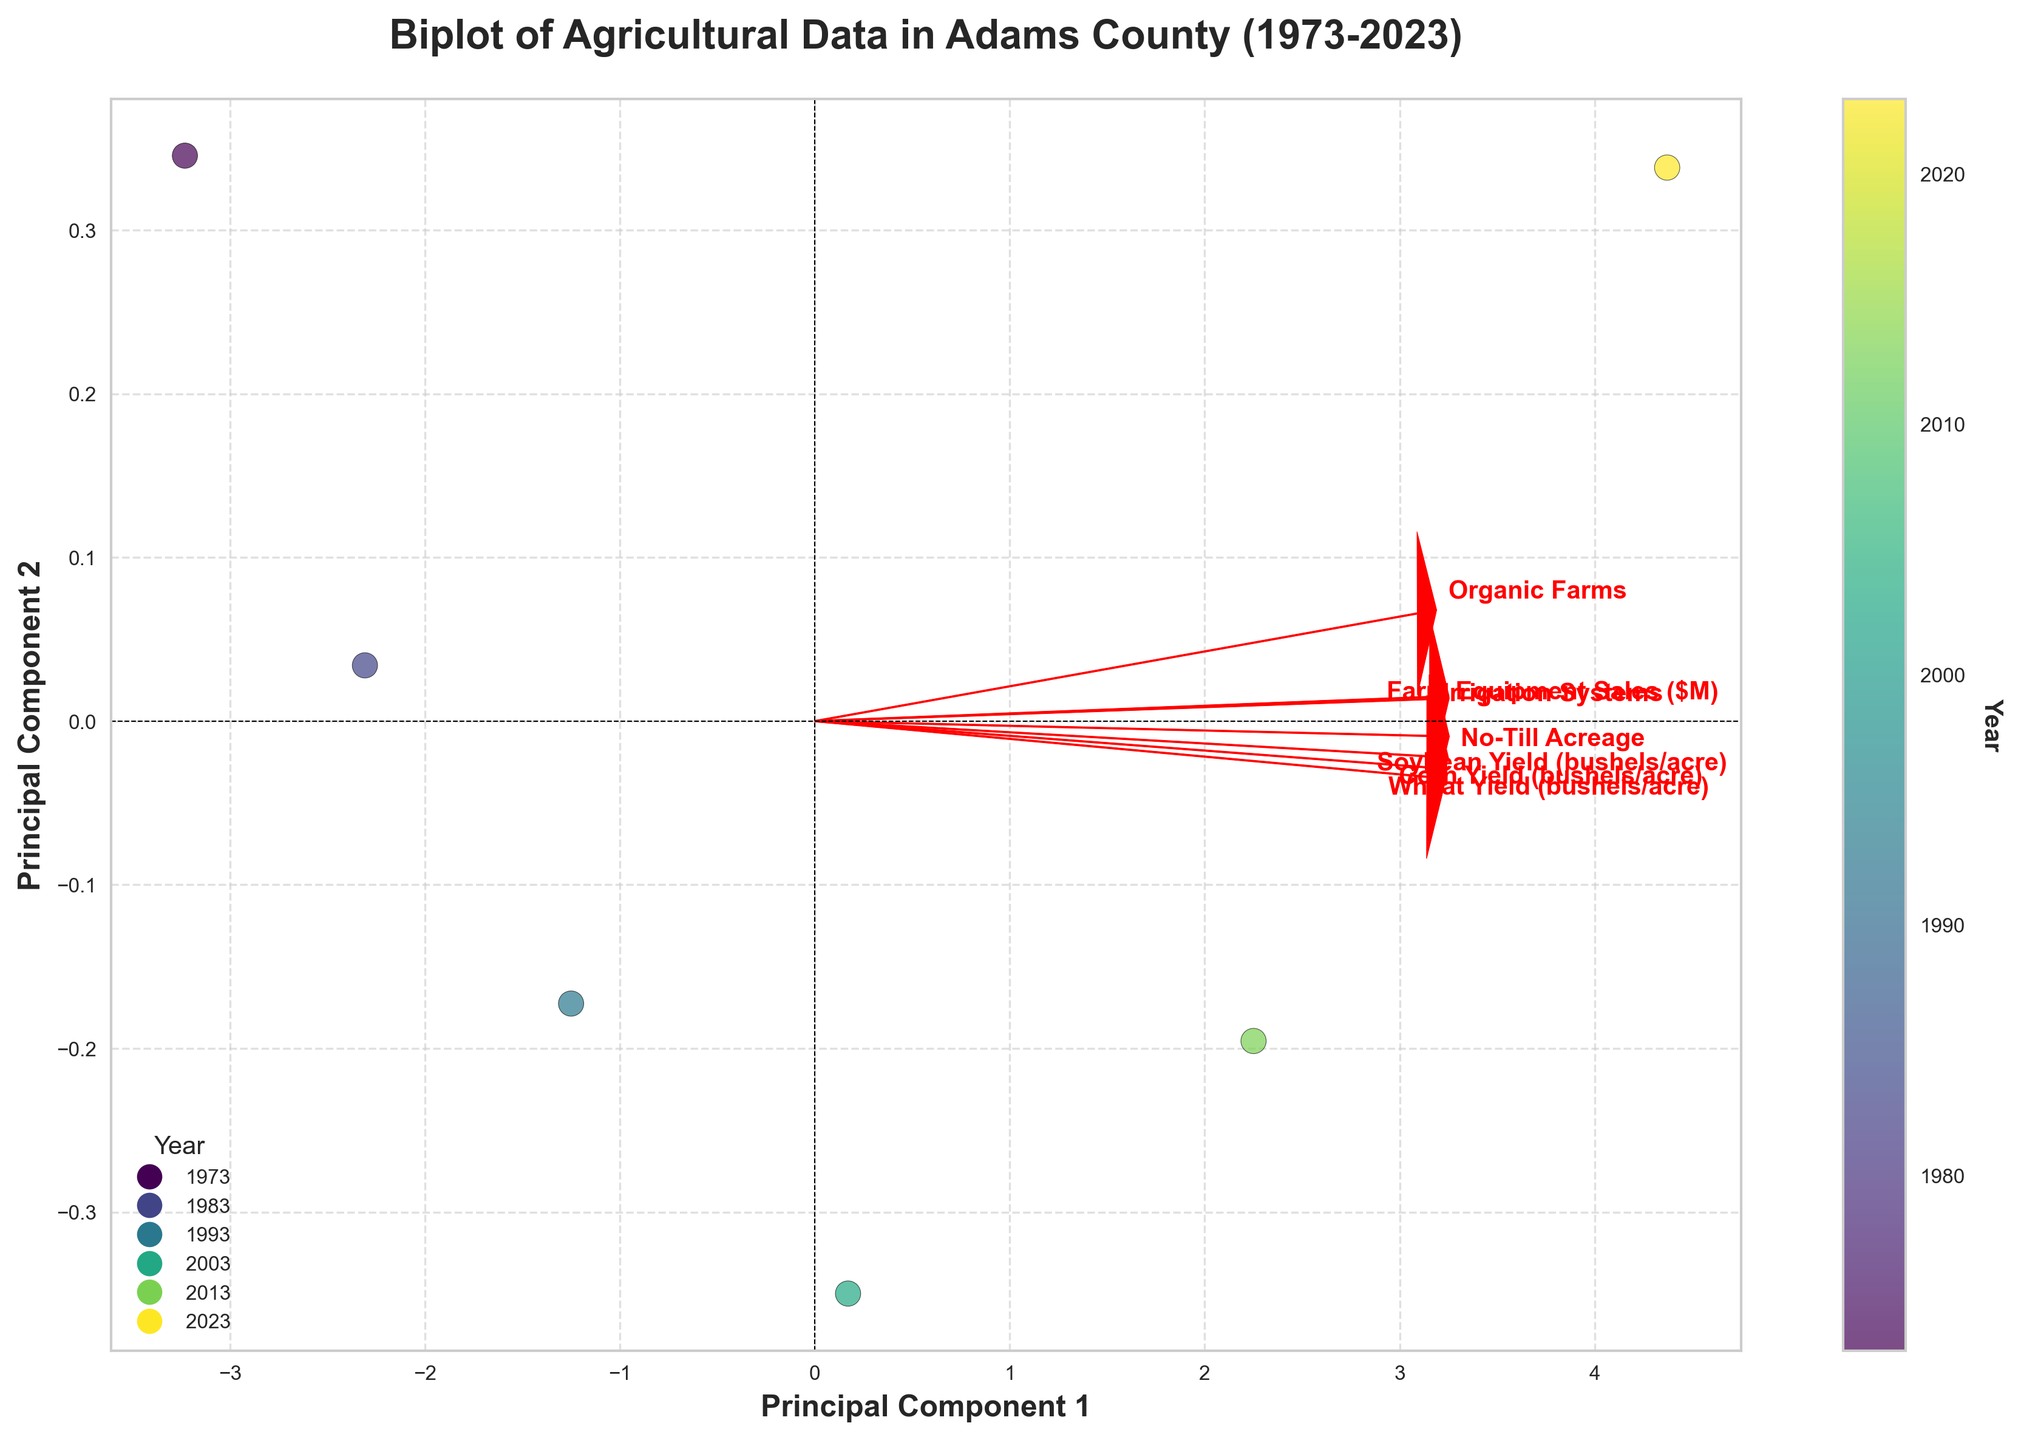what's the title of the plot? The title is typically located at the top of the figure and is expressed in a bold font to catch the viewer’s attention.
Answer: Biplot of Agricultural Data in Adams County (1973-2023) How many data points are displayed in the figure? The number of data points corresponds to the number of years included in the dataset, each represented by a unique marker in the scatter plot.
Answer: 6 Which year has the largest value on Principal Component 1? Locate the data point furthest along the positive side of the x-axis (representing Principal Component 1) by following the axis and seeing which year label it corresponds to.
Answer: 2023 What's the trend in the color gradient of the data points? Observe the color gradient on the plot, which likely follows the chronological order of the years because the color bar indicates 'Year' from earlier to more recent years.
Answer: From dark to light Which farming method saw the biggest increase in eigenvector length over time? Look for the farming method whose arrow representing the eigenvector grows more significantly from the center. Longer arrows mean a larger contribution to the principal components.
Answer: Irrigation Systems Is "Farm Equipment Sales" more aligned with Principal Component 1 or Principal Component 2? Check the orientation of the arrow labeled "Farm Equipment Sales" in relation to the x-axis (PC1) and y-axis (PC2).
Answer: Principal Component 1 In what range did the Corn Yield (bushels/acre) increase in the data points shown? Look at the spread of data points and check the range of Corn Yield values presented in the scatter plot, from the lowest to the highest value.
Answer: 80 to 175 bushels/acre How does the spread of the data points indicate the variance explained by Principal Components? Look at how widely the data points are spread out along the x- and y-axes; more spread along an axis indicates greater variance explained by that Principal Component.
Answer: PC1 explains more variance Which two variables seem to have the strongest relationship based on their eigenvectors? Observe the plot for arrows pointing in the same direction or close to each other, indicating a strong relationship.
Answer: No-Till Acreage and Irrigation Systems 